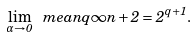<formula> <loc_0><loc_0><loc_500><loc_500>\lim _ { \alpha \to 0 } \ m e a n q { \infty } { n + 2 } = 2 ^ { q + 1 } .</formula> 